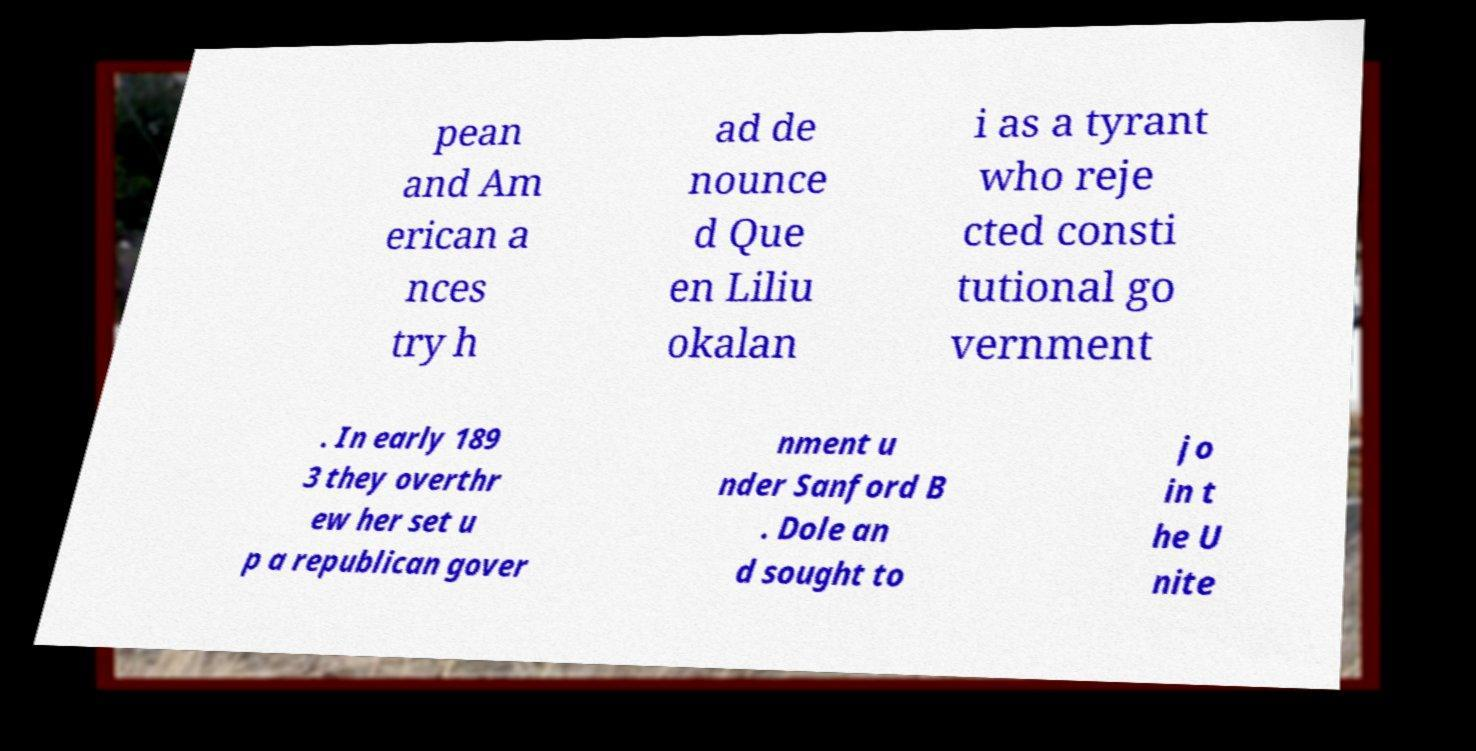Could you assist in decoding the text presented in this image and type it out clearly? pean and Am erican a nces try h ad de nounce d Que en Liliu okalan i as a tyrant who reje cted consti tutional go vernment . In early 189 3 they overthr ew her set u p a republican gover nment u nder Sanford B . Dole an d sought to jo in t he U nite 